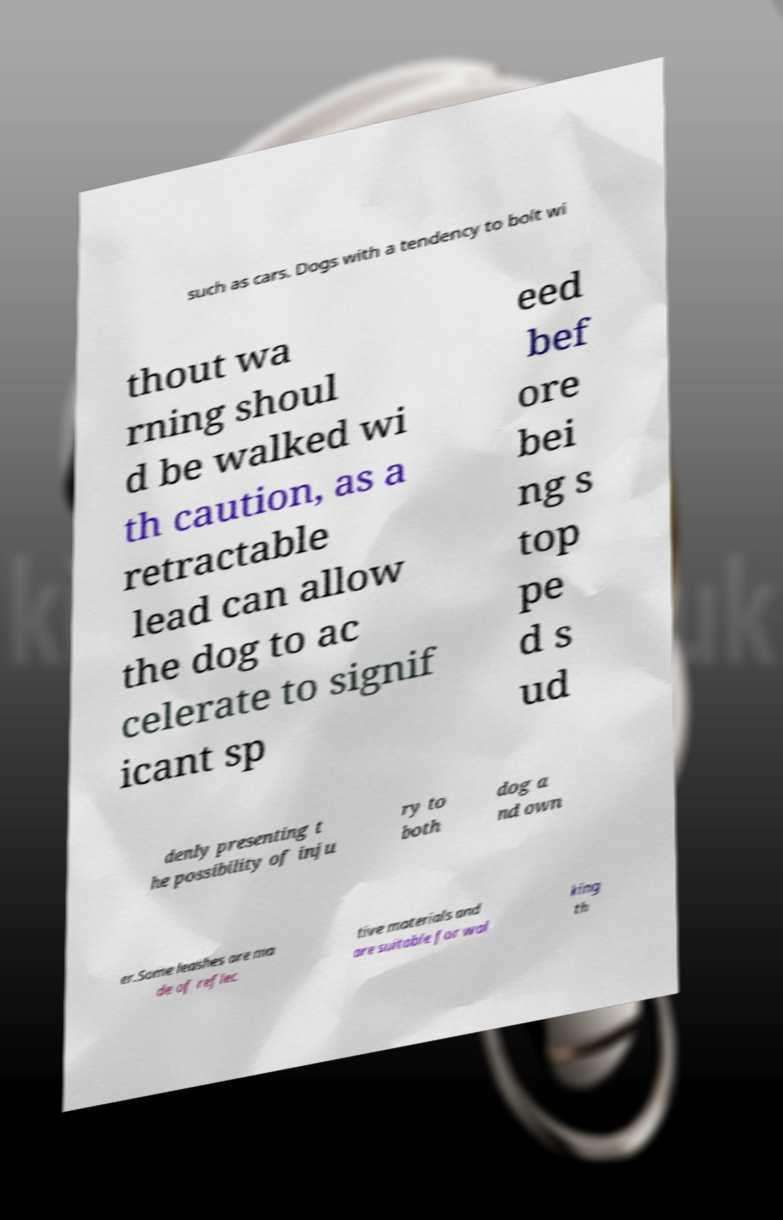Can you accurately transcribe the text from the provided image for me? such as cars. Dogs with a tendency to bolt wi thout wa rning shoul d be walked wi th caution, as a retractable lead can allow the dog to ac celerate to signif icant sp eed bef ore bei ng s top pe d s ud denly presenting t he possibility of inju ry to both dog a nd own er.Some leashes are ma de of reflec tive materials and are suitable for wal king th 